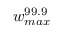<formula> <loc_0><loc_0><loc_500><loc_500>w _ { \max } ^ { 9 9 . 9 }</formula> 